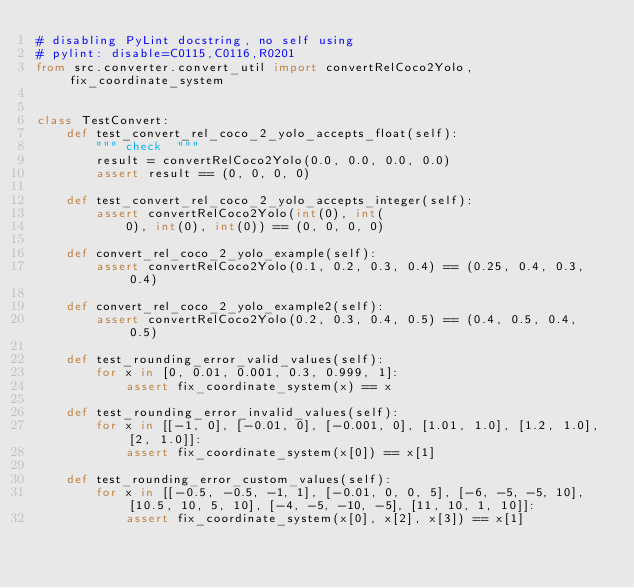Convert code to text. <code><loc_0><loc_0><loc_500><loc_500><_Python_># disabling PyLint docstring, no self using
# pylint: disable=C0115,C0116,R0201
from src.converter.convert_util import convertRelCoco2Yolo, fix_coordinate_system


class TestConvert:
    def test_convert_rel_coco_2_yolo_accepts_float(self):
        """ check  """
        result = convertRelCoco2Yolo(0.0, 0.0, 0.0, 0.0)
        assert result == (0, 0, 0, 0)

    def test_convert_rel_coco_2_yolo_accepts_integer(self):
        assert convertRelCoco2Yolo(int(0), int(
            0), int(0), int(0)) == (0, 0, 0, 0)

    def convert_rel_coco_2_yolo_example(self):
        assert convertRelCoco2Yolo(0.1, 0.2, 0.3, 0.4) == (0.25, 0.4, 0.3, 0.4)

    def convert_rel_coco_2_yolo_example2(self):
        assert convertRelCoco2Yolo(0.2, 0.3, 0.4, 0.5) == (0.4, 0.5, 0.4, 0.5)

    def test_rounding_error_valid_values(self):
        for x in [0, 0.01, 0.001, 0.3, 0.999, 1]:
            assert fix_coordinate_system(x) == x

    def test_rounding_error_invalid_values(self):
        for x in [[-1, 0], [-0.01, 0], [-0.001, 0], [1.01, 1.0], [1.2, 1.0], [2, 1.0]]:
            assert fix_coordinate_system(x[0]) == x[1]

    def test_rounding_error_custom_values(self):
        for x in [[-0.5, -0.5, -1, 1], [-0.01, 0, 0, 5], [-6, -5, -5, 10], [10.5, 10, 5, 10], [-4, -5, -10, -5], [11, 10, 1, 10]]:
            assert fix_coordinate_system(x[0], x[2], x[3]) == x[1]
</code> 